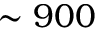Convert formula to latex. <formula><loc_0><loc_0><loc_500><loc_500>\sim 9 0 0</formula> 